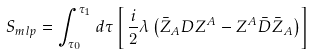Convert formula to latex. <formula><loc_0><loc_0><loc_500><loc_500>S _ { m l p } = \int _ { \tau _ { 0 } } ^ { \tau _ { 1 } } d \tau \left [ \, \frac { i } { 2 } \lambda \left ( \bar { Z } _ { A } D Z ^ { A } - Z ^ { A } \bar { D } \bar { Z } _ { A } \right ) \right ]</formula> 